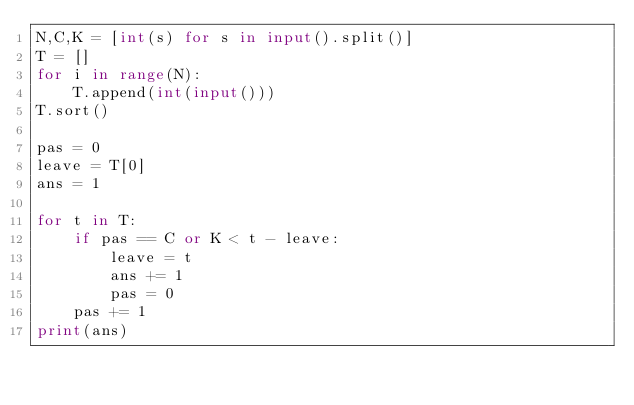Convert code to text. <code><loc_0><loc_0><loc_500><loc_500><_Python_>N,C,K = [int(s) for s in input().split()]
T = []
for i in range(N):
    T.append(int(input()))
T.sort()
 
pas = 0
leave = T[0]
ans = 1
 
for t in T:
    if pas == C or K < t - leave:
        leave = t
        ans += 1
        pas = 0
    pas += 1
print(ans)</code> 